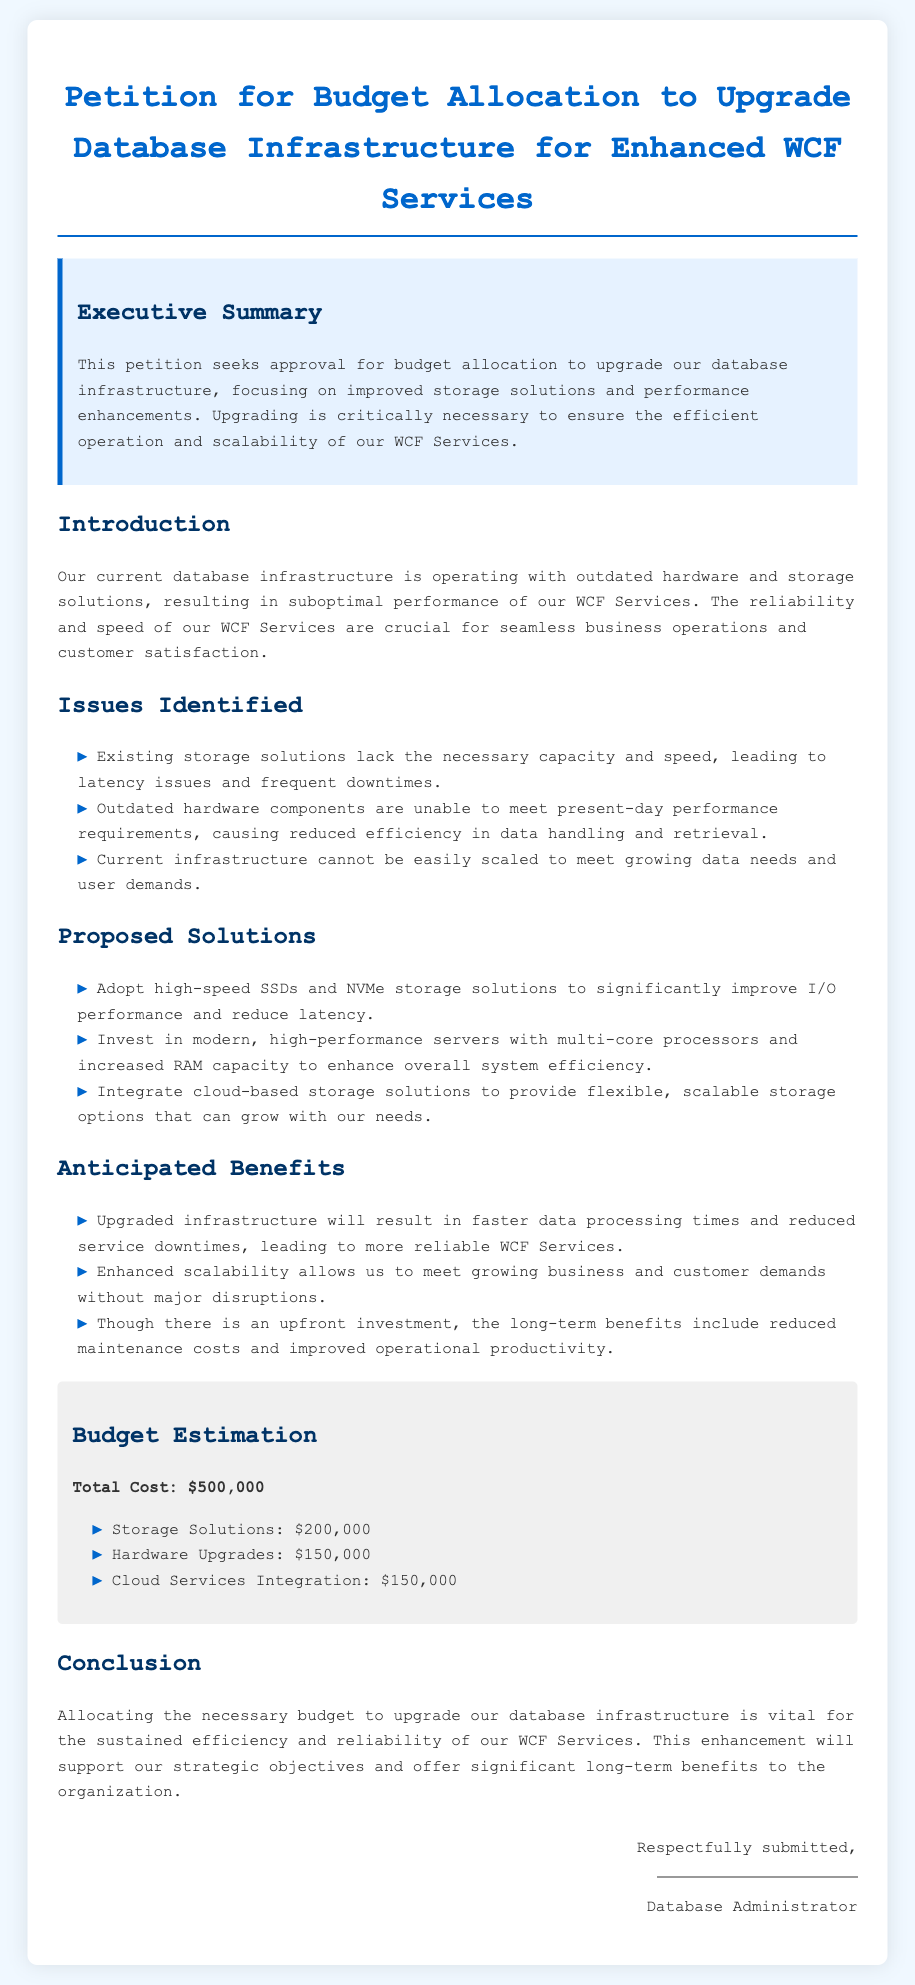What is the total cost for the database infrastructure upgrade? The total cost is detailed in the budget estimation section, which lists the expenses that sum up to $500,000.
Answer: $500,000 What type of storage solutions is proposed for the upgrade? The proposed storage solutions include high-speed SSDs and NVMe storage solutions intended to significantly improve performance.
Answer: SSDs and NVMe What hardware upgrades are suggested? The petition recommends investing in modern, high-performance servers with multi-core processors and increased RAM capacity to enhance efficiency.
Answer: Modern servers What is one of the anticipated benefits of the proposed upgrade? The anticipated benefits include faster data processing times and reduced service downtimes, which will lead to more reliable services.
Answer: Faster data processing What section follows the Executive Summary in the document? The order of sections in the document indicates that the section following the Executive Summary is the Introduction.
Answer: Introduction How much funding is allocated for cloud services integration? The budget estimation clearly outlines that the cost allocated for cloud services integration is $150,000.
Answer: $150,000 What is a significant issue identified in the current infrastructure? One significant issue mentioned is that outdated hardware components do not meet present-day performance requirements, leading to reduced efficiency.
Answer: Outdated hardware Who is the petition respectfully submitted by? The document indicates that the petition is respectfully submitted by the Database Administrator.
Answer: Database Administrator What color is used for the background of the document? The background color of the document is described as a light shade of blue (#f0f8ff).
Answer: Light blue 